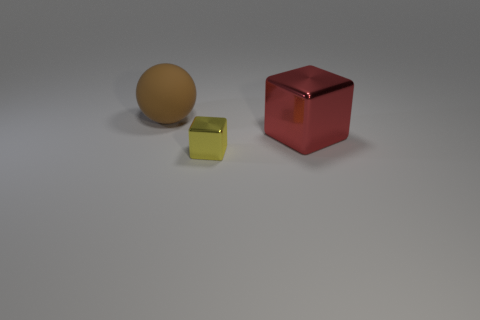Add 3 cubes. How many objects exist? 6 Subtract all balls. How many objects are left? 2 Subtract all red objects. Subtract all tiny red rubber things. How many objects are left? 2 Add 2 large rubber things. How many large rubber things are left? 3 Add 1 yellow cubes. How many yellow cubes exist? 2 Subtract 0 cyan cylinders. How many objects are left? 3 